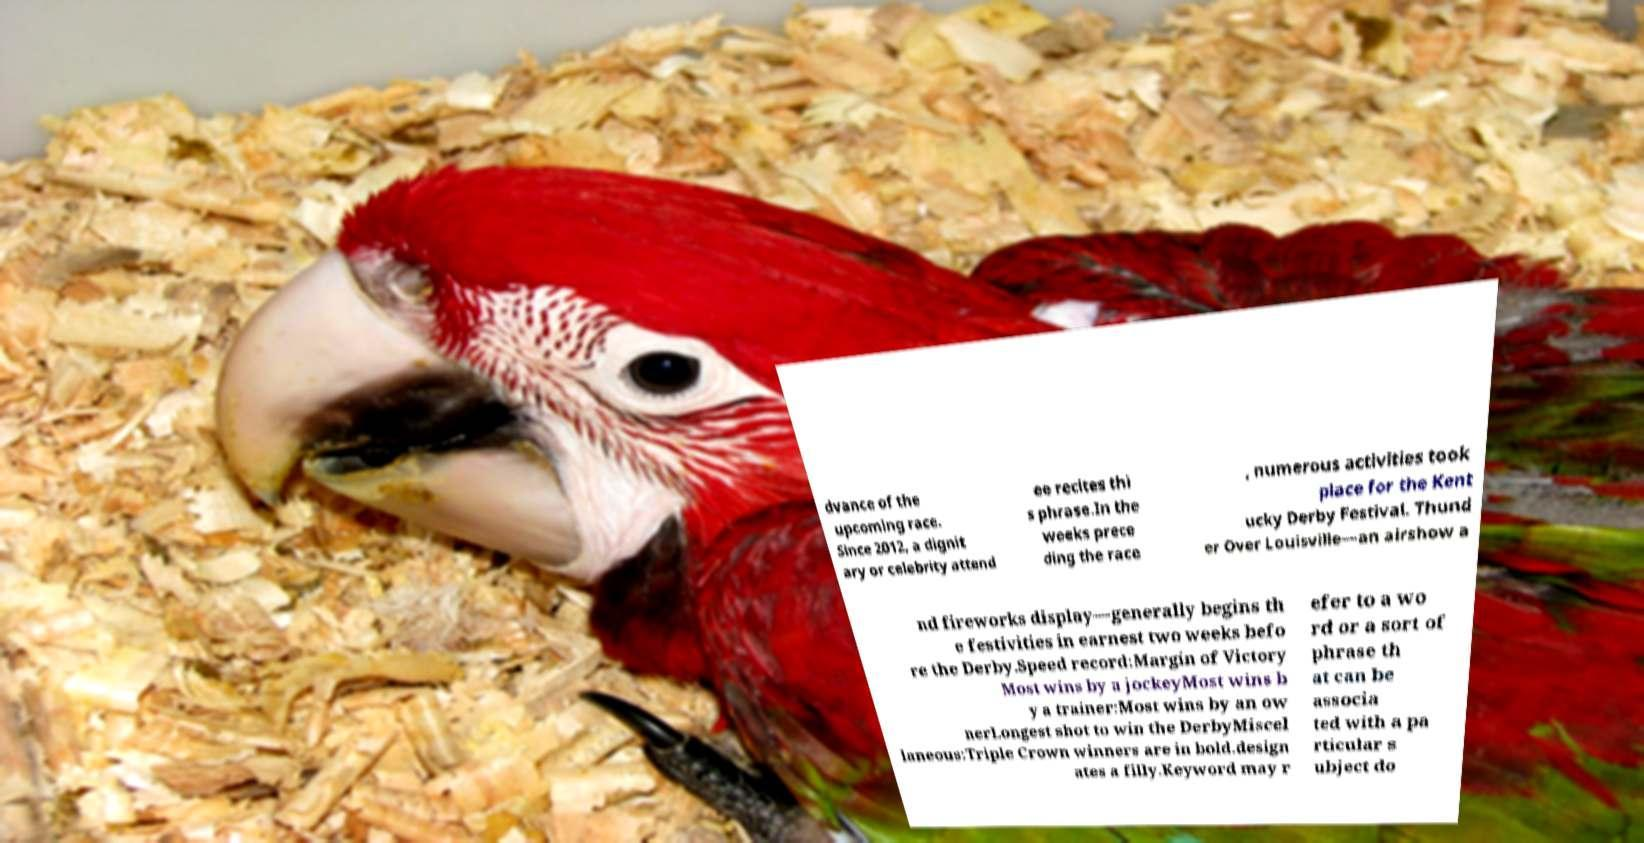Please identify and transcribe the text found in this image. dvance of the upcoming race. Since 2012, a dignit ary or celebrity attend ee recites thi s phrase.In the weeks prece ding the race , numerous activities took place for the Kent ucky Derby Festival. Thund er Over Louisville—an airshow a nd fireworks display—generally begins th e festivities in earnest two weeks befo re the Derby.Speed record:Margin of Victory Most wins by a jockeyMost wins b y a trainer:Most wins by an ow nerLongest shot to win the DerbyMiscel laneous:Triple Crown winners are in bold.design ates a filly.Keyword may r efer to a wo rd or a sort of phrase th at can be associa ted with a pa rticular s ubject do 